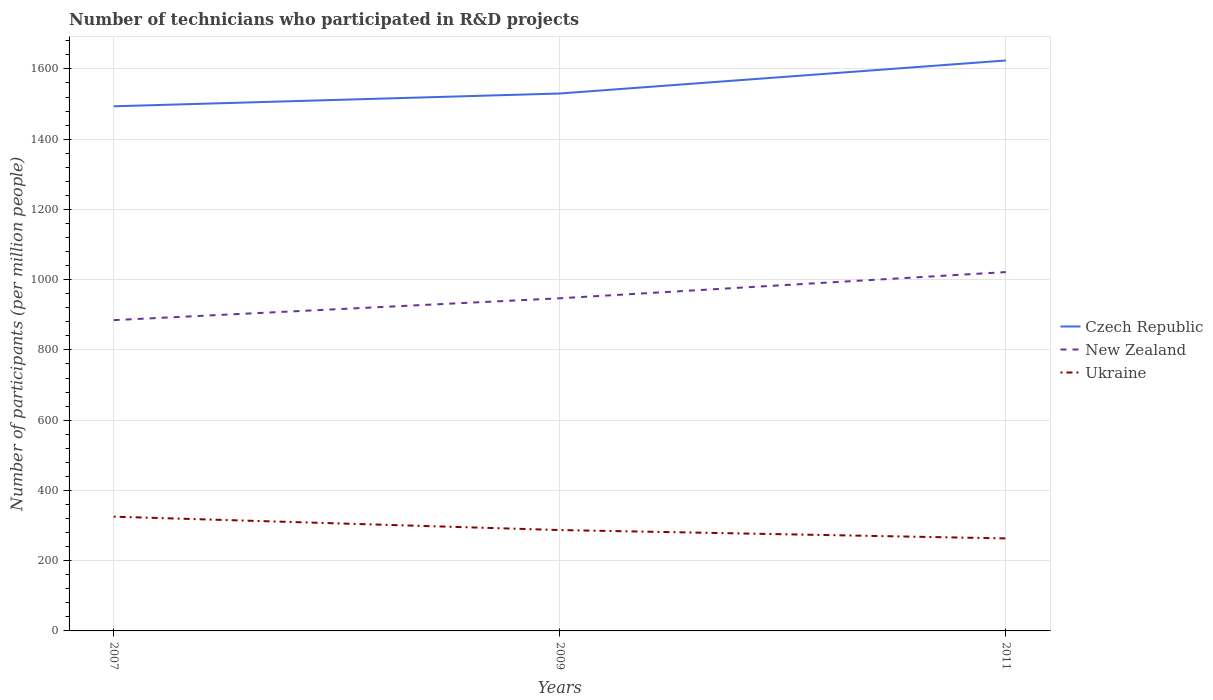Is the number of lines equal to the number of legend labels?
Keep it short and to the point. Yes. Across all years, what is the maximum number of technicians who participated in R&D projects in Ukraine?
Give a very brief answer. 263.36. In which year was the number of technicians who participated in R&D projects in New Zealand maximum?
Provide a short and direct response. 2007. What is the total number of technicians who participated in R&D projects in New Zealand in the graph?
Offer a terse response. -136.84. What is the difference between the highest and the second highest number of technicians who participated in R&D projects in New Zealand?
Make the answer very short. 136.84. How many years are there in the graph?
Make the answer very short. 3. Are the values on the major ticks of Y-axis written in scientific E-notation?
Offer a terse response. No. Where does the legend appear in the graph?
Keep it short and to the point. Center right. How are the legend labels stacked?
Keep it short and to the point. Vertical. What is the title of the graph?
Give a very brief answer. Number of technicians who participated in R&D projects. Does "Uruguay" appear as one of the legend labels in the graph?
Offer a very short reply. No. What is the label or title of the X-axis?
Keep it short and to the point. Years. What is the label or title of the Y-axis?
Make the answer very short. Number of participants (per million people). What is the Number of participants (per million people) in Czech Republic in 2007?
Your response must be concise. 1493.68. What is the Number of participants (per million people) in New Zealand in 2007?
Offer a very short reply. 884.85. What is the Number of participants (per million people) of Ukraine in 2007?
Your answer should be compact. 325.3. What is the Number of participants (per million people) of Czech Republic in 2009?
Keep it short and to the point. 1530.09. What is the Number of participants (per million people) in New Zealand in 2009?
Make the answer very short. 947.07. What is the Number of participants (per million people) of Ukraine in 2009?
Provide a succinct answer. 287.19. What is the Number of participants (per million people) in Czech Republic in 2011?
Keep it short and to the point. 1624.14. What is the Number of participants (per million people) in New Zealand in 2011?
Give a very brief answer. 1021.69. What is the Number of participants (per million people) of Ukraine in 2011?
Offer a very short reply. 263.36. Across all years, what is the maximum Number of participants (per million people) in Czech Republic?
Your answer should be compact. 1624.14. Across all years, what is the maximum Number of participants (per million people) of New Zealand?
Provide a succinct answer. 1021.69. Across all years, what is the maximum Number of participants (per million people) of Ukraine?
Your answer should be compact. 325.3. Across all years, what is the minimum Number of participants (per million people) in Czech Republic?
Your answer should be compact. 1493.68. Across all years, what is the minimum Number of participants (per million people) in New Zealand?
Provide a short and direct response. 884.85. Across all years, what is the minimum Number of participants (per million people) of Ukraine?
Your answer should be very brief. 263.36. What is the total Number of participants (per million people) of Czech Republic in the graph?
Keep it short and to the point. 4647.91. What is the total Number of participants (per million people) of New Zealand in the graph?
Provide a succinct answer. 2853.61. What is the total Number of participants (per million people) of Ukraine in the graph?
Make the answer very short. 875.85. What is the difference between the Number of participants (per million people) of Czech Republic in 2007 and that in 2009?
Your answer should be compact. -36.41. What is the difference between the Number of participants (per million people) of New Zealand in 2007 and that in 2009?
Give a very brief answer. -62.23. What is the difference between the Number of participants (per million people) of Ukraine in 2007 and that in 2009?
Your answer should be very brief. 38.11. What is the difference between the Number of participants (per million people) of Czech Republic in 2007 and that in 2011?
Offer a very short reply. -130.45. What is the difference between the Number of participants (per million people) of New Zealand in 2007 and that in 2011?
Make the answer very short. -136.84. What is the difference between the Number of participants (per million people) of Ukraine in 2007 and that in 2011?
Offer a terse response. 61.94. What is the difference between the Number of participants (per million people) in Czech Republic in 2009 and that in 2011?
Ensure brevity in your answer.  -94.04. What is the difference between the Number of participants (per million people) of New Zealand in 2009 and that in 2011?
Your response must be concise. -74.61. What is the difference between the Number of participants (per million people) in Ukraine in 2009 and that in 2011?
Provide a short and direct response. 23.83. What is the difference between the Number of participants (per million people) in Czech Republic in 2007 and the Number of participants (per million people) in New Zealand in 2009?
Make the answer very short. 546.61. What is the difference between the Number of participants (per million people) of Czech Republic in 2007 and the Number of participants (per million people) of Ukraine in 2009?
Give a very brief answer. 1206.49. What is the difference between the Number of participants (per million people) in New Zealand in 2007 and the Number of participants (per million people) in Ukraine in 2009?
Offer a very short reply. 597.66. What is the difference between the Number of participants (per million people) of Czech Republic in 2007 and the Number of participants (per million people) of New Zealand in 2011?
Provide a short and direct response. 472. What is the difference between the Number of participants (per million people) in Czech Republic in 2007 and the Number of participants (per million people) in Ukraine in 2011?
Provide a short and direct response. 1230.32. What is the difference between the Number of participants (per million people) of New Zealand in 2007 and the Number of participants (per million people) of Ukraine in 2011?
Ensure brevity in your answer.  621.49. What is the difference between the Number of participants (per million people) of Czech Republic in 2009 and the Number of participants (per million people) of New Zealand in 2011?
Provide a succinct answer. 508.41. What is the difference between the Number of participants (per million people) in Czech Republic in 2009 and the Number of participants (per million people) in Ukraine in 2011?
Offer a very short reply. 1266.73. What is the difference between the Number of participants (per million people) in New Zealand in 2009 and the Number of participants (per million people) in Ukraine in 2011?
Offer a terse response. 683.71. What is the average Number of participants (per million people) in Czech Republic per year?
Ensure brevity in your answer.  1549.3. What is the average Number of participants (per million people) of New Zealand per year?
Your answer should be compact. 951.2. What is the average Number of participants (per million people) of Ukraine per year?
Give a very brief answer. 291.95. In the year 2007, what is the difference between the Number of participants (per million people) in Czech Republic and Number of participants (per million people) in New Zealand?
Your answer should be very brief. 608.84. In the year 2007, what is the difference between the Number of participants (per million people) in Czech Republic and Number of participants (per million people) in Ukraine?
Ensure brevity in your answer.  1168.38. In the year 2007, what is the difference between the Number of participants (per million people) of New Zealand and Number of participants (per million people) of Ukraine?
Make the answer very short. 559.54. In the year 2009, what is the difference between the Number of participants (per million people) of Czech Republic and Number of participants (per million people) of New Zealand?
Keep it short and to the point. 583.02. In the year 2009, what is the difference between the Number of participants (per million people) of Czech Republic and Number of participants (per million people) of Ukraine?
Make the answer very short. 1242.9. In the year 2009, what is the difference between the Number of participants (per million people) in New Zealand and Number of participants (per million people) in Ukraine?
Ensure brevity in your answer.  659.88. In the year 2011, what is the difference between the Number of participants (per million people) in Czech Republic and Number of participants (per million people) in New Zealand?
Keep it short and to the point. 602.45. In the year 2011, what is the difference between the Number of participants (per million people) of Czech Republic and Number of participants (per million people) of Ukraine?
Your answer should be compact. 1360.78. In the year 2011, what is the difference between the Number of participants (per million people) of New Zealand and Number of participants (per million people) of Ukraine?
Offer a very short reply. 758.33. What is the ratio of the Number of participants (per million people) of Czech Republic in 2007 to that in 2009?
Your answer should be compact. 0.98. What is the ratio of the Number of participants (per million people) of New Zealand in 2007 to that in 2009?
Provide a short and direct response. 0.93. What is the ratio of the Number of participants (per million people) in Ukraine in 2007 to that in 2009?
Offer a very short reply. 1.13. What is the ratio of the Number of participants (per million people) of Czech Republic in 2007 to that in 2011?
Make the answer very short. 0.92. What is the ratio of the Number of participants (per million people) in New Zealand in 2007 to that in 2011?
Your answer should be very brief. 0.87. What is the ratio of the Number of participants (per million people) of Ukraine in 2007 to that in 2011?
Your response must be concise. 1.24. What is the ratio of the Number of participants (per million people) in Czech Republic in 2009 to that in 2011?
Offer a very short reply. 0.94. What is the ratio of the Number of participants (per million people) in New Zealand in 2009 to that in 2011?
Give a very brief answer. 0.93. What is the ratio of the Number of participants (per million people) in Ukraine in 2009 to that in 2011?
Your answer should be compact. 1.09. What is the difference between the highest and the second highest Number of participants (per million people) of Czech Republic?
Offer a terse response. 94.04. What is the difference between the highest and the second highest Number of participants (per million people) in New Zealand?
Offer a terse response. 74.61. What is the difference between the highest and the second highest Number of participants (per million people) of Ukraine?
Your answer should be compact. 38.11. What is the difference between the highest and the lowest Number of participants (per million people) in Czech Republic?
Provide a succinct answer. 130.45. What is the difference between the highest and the lowest Number of participants (per million people) of New Zealand?
Provide a succinct answer. 136.84. What is the difference between the highest and the lowest Number of participants (per million people) in Ukraine?
Provide a short and direct response. 61.94. 